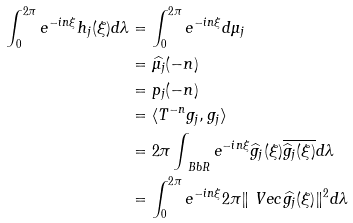Convert formula to latex. <formula><loc_0><loc_0><loc_500><loc_500>\int _ { 0 } ^ { 2 \pi } e ^ { - i n \xi } h _ { j } ( \xi ) d \lambda & = \int _ { 0 } ^ { 2 \pi } e ^ { - i n \xi } d \mu _ { j } \\ & = \widehat { \mu _ { j } } ( - n ) \\ & = p _ { j } ( - n ) \\ & = \langle T ^ { - n } g _ { j } , g _ { j } \rangle \\ & = 2 \pi \int _ { \ B b { R } } e ^ { - i n \xi } \widehat { g } _ { j } ( \xi ) \overline { \widehat { g } _ { j } ( \xi ) } d \lambda \\ & = \int _ { 0 } ^ { 2 \pi } e ^ { - i n \xi } 2 \pi \| \ V e c { \widehat { g _ { j } } } ( \xi ) \| ^ { 2 } d \lambda</formula> 